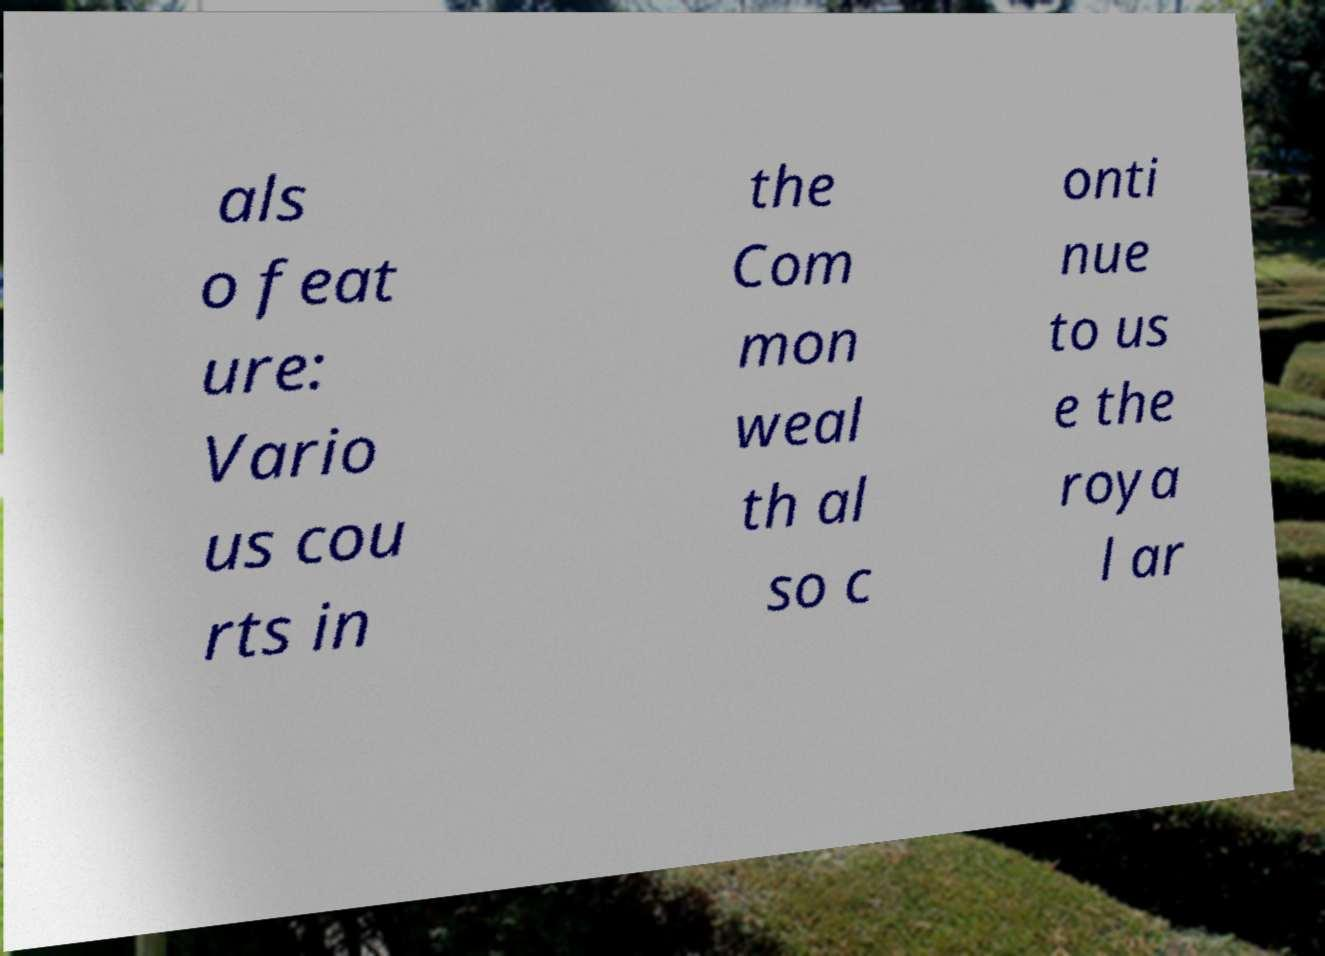Can you read and provide the text displayed in the image?This photo seems to have some interesting text. Can you extract and type it out for me? als o feat ure: Vario us cou rts in the Com mon weal th al so c onti nue to us e the roya l ar 